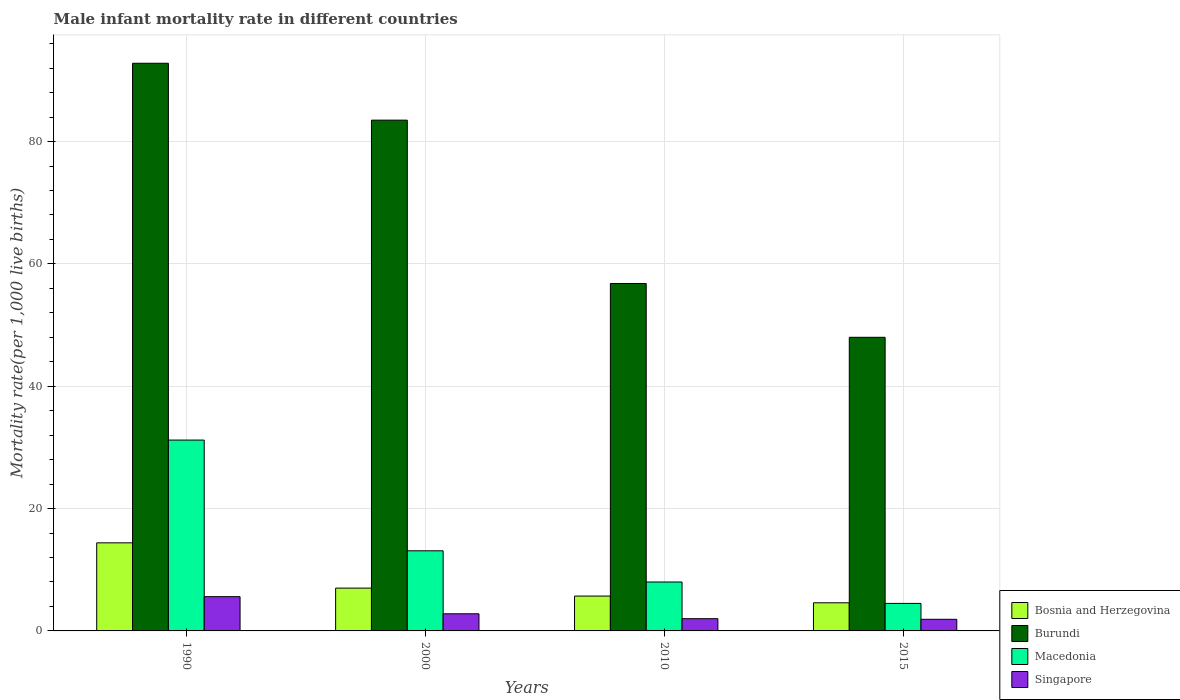How many groups of bars are there?
Keep it short and to the point. 4. Are the number of bars per tick equal to the number of legend labels?
Give a very brief answer. Yes. Are the number of bars on each tick of the X-axis equal?
Your response must be concise. Yes. How many bars are there on the 2nd tick from the left?
Your answer should be compact. 4. How many bars are there on the 3rd tick from the right?
Provide a short and direct response. 4. What is the label of the 2nd group of bars from the left?
Keep it short and to the point. 2000. What is the male infant mortality rate in Burundi in 1990?
Keep it short and to the point. 92.8. Across all years, what is the maximum male infant mortality rate in Bosnia and Herzegovina?
Ensure brevity in your answer.  14.4. Across all years, what is the minimum male infant mortality rate in Singapore?
Give a very brief answer. 1.9. In which year was the male infant mortality rate in Bosnia and Herzegovina minimum?
Provide a succinct answer. 2015. What is the total male infant mortality rate in Macedonia in the graph?
Offer a terse response. 56.8. What is the difference between the male infant mortality rate in Burundi in 2000 and the male infant mortality rate in Bosnia and Herzegovina in 1990?
Your answer should be compact. 69.1. What is the average male infant mortality rate in Bosnia and Herzegovina per year?
Your answer should be very brief. 7.92. In the year 2000, what is the difference between the male infant mortality rate in Singapore and male infant mortality rate in Macedonia?
Offer a terse response. -10.3. What is the ratio of the male infant mortality rate in Singapore in 1990 to that in 2015?
Keep it short and to the point. 2.95. Is the male infant mortality rate in Burundi in 2000 less than that in 2015?
Give a very brief answer. No. In how many years, is the male infant mortality rate in Macedonia greater than the average male infant mortality rate in Macedonia taken over all years?
Your response must be concise. 1. Is the sum of the male infant mortality rate in Macedonia in 1990 and 2010 greater than the maximum male infant mortality rate in Singapore across all years?
Offer a terse response. Yes. What does the 4th bar from the left in 1990 represents?
Your answer should be compact. Singapore. What does the 1st bar from the right in 2010 represents?
Your response must be concise. Singapore. Are all the bars in the graph horizontal?
Provide a short and direct response. No. What is the difference between two consecutive major ticks on the Y-axis?
Make the answer very short. 20. Are the values on the major ticks of Y-axis written in scientific E-notation?
Keep it short and to the point. No. Where does the legend appear in the graph?
Make the answer very short. Bottom right. What is the title of the graph?
Make the answer very short. Male infant mortality rate in different countries. Does "Samoa" appear as one of the legend labels in the graph?
Keep it short and to the point. No. What is the label or title of the Y-axis?
Your answer should be compact. Mortality rate(per 1,0 live births). What is the Mortality rate(per 1,000 live births) in Bosnia and Herzegovina in 1990?
Your response must be concise. 14.4. What is the Mortality rate(per 1,000 live births) in Burundi in 1990?
Provide a succinct answer. 92.8. What is the Mortality rate(per 1,000 live births) of Macedonia in 1990?
Your answer should be compact. 31.2. What is the Mortality rate(per 1,000 live births) of Bosnia and Herzegovina in 2000?
Provide a short and direct response. 7. What is the Mortality rate(per 1,000 live births) in Burundi in 2000?
Your answer should be compact. 83.5. What is the Mortality rate(per 1,000 live births) of Macedonia in 2000?
Give a very brief answer. 13.1. What is the Mortality rate(per 1,000 live births) in Bosnia and Herzegovina in 2010?
Offer a terse response. 5.7. What is the Mortality rate(per 1,000 live births) of Burundi in 2010?
Offer a terse response. 56.8. What is the Mortality rate(per 1,000 live births) of Singapore in 2010?
Your response must be concise. 2. What is the Mortality rate(per 1,000 live births) of Bosnia and Herzegovina in 2015?
Make the answer very short. 4.6. What is the Mortality rate(per 1,000 live births) in Burundi in 2015?
Provide a short and direct response. 48. What is the Mortality rate(per 1,000 live births) in Macedonia in 2015?
Give a very brief answer. 4.5. What is the Mortality rate(per 1,000 live births) in Singapore in 2015?
Provide a succinct answer. 1.9. Across all years, what is the maximum Mortality rate(per 1,000 live births) in Burundi?
Your answer should be compact. 92.8. Across all years, what is the maximum Mortality rate(per 1,000 live births) of Macedonia?
Offer a terse response. 31.2. Across all years, what is the minimum Mortality rate(per 1,000 live births) of Burundi?
Your answer should be compact. 48. Across all years, what is the minimum Mortality rate(per 1,000 live births) in Macedonia?
Provide a succinct answer. 4.5. What is the total Mortality rate(per 1,000 live births) of Bosnia and Herzegovina in the graph?
Your response must be concise. 31.7. What is the total Mortality rate(per 1,000 live births) of Burundi in the graph?
Provide a succinct answer. 281.1. What is the total Mortality rate(per 1,000 live births) of Macedonia in the graph?
Give a very brief answer. 56.8. What is the total Mortality rate(per 1,000 live births) of Singapore in the graph?
Your answer should be very brief. 12.3. What is the difference between the Mortality rate(per 1,000 live births) in Macedonia in 1990 and that in 2000?
Your answer should be very brief. 18.1. What is the difference between the Mortality rate(per 1,000 live births) in Singapore in 1990 and that in 2000?
Ensure brevity in your answer.  2.8. What is the difference between the Mortality rate(per 1,000 live births) in Bosnia and Herzegovina in 1990 and that in 2010?
Offer a terse response. 8.7. What is the difference between the Mortality rate(per 1,000 live births) in Macedonia in 1990 and that in 2010?
Make the answer very short. 23.2. What is the difference between the Mortality rate(per 1,000 live births) in Singapore in 1990 and that in 2010?
Make the answer very short. 3.6. What is the difference between the Mortality rate(per 1,000 live births) in Burundi in 1990 and that in 2015?
Your answer should be very brief. 44.8. What is the difference between the Mortality rate(per 1,000 live births) in Macedonia in 1990 and that in 2015?
Offer a terse response. 26.7. What is the difference between the Mortality rate(per 1,000 live births) of Bosnia and Herzegovina in 2000 and that in 2010?
Ensure brevity in your answer.  1.3. What is the difference between the Mortality rate(per 1,000 live births) in Burundi in 2000 and that in 2010?
Your answer should be very brief. 26.7. What is the difference between the Mortality rate(per 1,000 live births) of Macedonia in 2000 and that in 2010?
Your answer should be very brief. 5.1. What is the difference between the Mortality rate(per 1,000 live births) in Bosnia and Herzegovina in 2000 and that in 2015?
Provide a succinct answer. 2.4. What is the difference between the Mortality rate(per 1,000 live births) of Burundi in 2000 and that in 2015?
Offer a terse response. 35.5. What is the difference between the Mortality rate(per 1,000 live births) of Macedonia in 2000 and that in 2015?
Give a very brief answer. 8.6. What is the difference between the Mortality rate(per 1,000 live births) in Bosnia and Herzegovina in 2010 and that in 2015?
Keep it short and to the point. 1.1. What is the difference between the Mortality rate(per 1,000 live births) of Bosnia and Herzegovina in 1990 and the Mortality rate(per 1,000 live births) of Burundi in 2000?
Your response must be concise. -69.1. What is the difference between the Mortality rate(per 1,000 live births) of Bosnia and Herzegovina in 1990 and the Mortality rate(per 1,000 live births) of Macedonia in 2000?
Make the answer very short. 1.3. What is the difference between the Mortality rate(per 1,000 live births) of Bosnia and Herzegovina in 1990 and the Mortality rate(per 1,000 live births) of Singapore in 2000?
Offer a very short reply. 11.6. What is the difference between the Mortality rate(per 1,000 live births) in Burundi in 1990 and the Mortality rate(per 1,000 live births) in Macedonia in 2000?
Make the answer very short. 79.7. What is the difference between the Mortality rate(per 1,000 live births) of Burundi in 1990 and the Mortality rate(per 1,000 live births) of Singapore in 2000?
Make the answer very short. 90. What is the difference between the Mortality rate(per 1,000 live births) in Macedonia in 1990 and the Mortality rate(per 1,000 live births) in Singapore in 2000?
Offer a terse response. 28.4. What is the difference between the Mortality rate(per 1,000 live births) in Bosnia and Herzegovina in 1990 and the Mortality rate(per 1,000 live births) in Burundi in 2010?
Offer a terse response. -42.4. What is the difference between the Mortality rate(per 1,000 live births) of Burundi in 1990 and the Mortality rate(per 1,000 live births) of Macedonia in 2010?
Make the answer very short. 84.8. What is the difference between the Mortality rate(per 1,000 live births) of Burundi in 1990 and the Mortality rate(per 1,000 live births) of Singapore in 2010?
Provide a succinct answer. 90.8. What is the difference between the Mortality rate(per 1,000 live births) of Macedonia in 1990 and the Mortality rate(per 1,000 live births) of Singapore in 2010?
Give a very brief answer. 29.2. What is the difference between the Mortality rate(per 1,000 live births) in Bosnia and Herzegovina in 1990 and the Mortality rate(per 1,000 live births) in Burundi in 2015?
Make the answer very short. -33.6. What is the difference between the Mortality rate(per 1,000 live births) in Bosnia and Herzegovina in 1990 and the Mortality rate(per 1,000 live births) in Macedonia in 2015?
Your answer should be very brief. 9.9. What is the difference between the Mortality rate(per 1,000 live births) of Burundi in 1990 and the Mortality rate(per 1,000 live births) of Macedonia in 2015?
Give a very brief answer. 88.3. What is the difference between the Mortality rate(per 1,000 live births) of Burundi in 1990 and the Mortality rate(per 1,000 live births) of Singapore in 2015?
Provide a short and direct response. 90.9. What is the difference between the Mortality rate(per 1,000 live births) in Macedonia in 1990 and the Mortality rate(per 1,000 live births) in Singapore in 2015?
Your response must be concise. 29.3. What is the difference between the Mortality rate(per 1,000 live births) of Bosnia and Herzegovina in 2000 and the Mortality rate(per 1,000 live births) of Burundi in 2010?
Offer a terse response. -49.8. What is the difference between the Mortality rate(per 1,000 live births) in Burundi in 2000 and the Mortality rate(per 1,000 live births) in Macedonia in 2010?
Make the answer very short. 75.5. What is the difference between the Mortality rate(per 1,000 live births) of Burundi in 2000 and the Mortality rate(per 1,000 live births) of Singapore in 2010?
Give a very brief answer. 81.5. What is the difference between the Mortality rate(per 1,000 live births) of Macedonia in 2000 and the Mortality rate(per 1,000 live births) of Singapore in 2010?
Give a very brief answer. 11.1. What is the difference between the Mortality rate(per 1,000 live births) in Bosnia and Herzegovina in 2000 and the Mortality rate(per 1,000 live births) in Burundi in 2015?
Make the answer very short. -41. What is the difference between the Mortality rate(per 1,000 live births) of Bosnia and Herzegovina in 2000 and the Mortality rate(per 1,000 live births) of Macedonia in 2015?
Your response must be concise. 2.5. What is the difference between the Mortality rate(per 1,000 live births) in Bosnia and Herzegovina in 2000 and the Mortality rate(per 1,000 live births) in Singapore in 2015?
Your answer should be compact. 5.1. What is the difference between the Mortality rate(per 1,000 live births) in Burundi in 2000 and the Mortality rate(per 1,000 live births) in Macedonia in 2015?
Your answer should be compact. 79. What is the difference between the Mortality rate(per 1,000 live births) in Burundi in 2000 and the Mortality rate(per 1,000 live births) in Singapore in 2015?
Ensure brevity in your answer.  81.6. What is the difference between the Mortality rate(per 1,000 live births) in Macedonia in 2000 and the Mortality rate(per 1,000 live births) in Singapore in 2015?
Your answer should be very brief. 11.2. What is the difference between the Mortality rate(per 1,000 live births) in Bosnia and Herzegovina in 2010 and the Mortality rate(per 1,000 live births) in Burundi in 2015?
Provide a short and direct response. -42.3. What is the difference between the Mortality rate(per 1,000 live births) of Burundi in 2010 and the Mortality rate(per 1,000 live births) of Macedonia in 2015?
Offer a very short reply. 52.3. What is the difference between the Mortality rate(per 1,000 live births) of Burundi in 2010 and the Mortality rate(per 1,000 live births) of Singapore in 2015?
Offer a very short reply. 54.9. What is the average Mortality rate(per 1,000 live births) in Bosnia and Herzegovina per year?
Provide a succinct answer. 7.92. What is the average Mortality rate(per 1,000 live births) of Burundi per year?
Keep it short and to the point. 70.28. What is the average Mortality rate(per 1,000 live births) in Singapore per year?
Make the answer very short. 3.08. In the year 1990, what is the difference between the Mortality rate(per 1,000 live births) in Bosnia and Herzegovina and Mortality rate(per 1,000 live births) in Burundi?
Ensure brevity in your answer.  -78.4. In the year 1990, what is the difference between the Mortality rate(per 1,000 live births) of Bosnia and Herzegovina and Mortality rate(per 1,000 live births) of Macedonia?
Offer a very short reply. -16.8. In the year 1990, what is the difference between the Mortality rate(per 1,000 live births) of Burundi and Mortality rate(per 1,000 live births) of Macedonia?
Your answer should be very brief. 61.6. In the year 1990, what is the difference between the Mortality rate(per 1,000 live births) of Burundi and Mortality rate(per 1,000 live births) of Singapore?
Offer a terse response. 87.2. In the year 1990, what is the difference between the Mortality rate(per 1,000 live births) of Macedonia and Mortality rate(per 1,000 live births) of Singapore?
Your response must be concise. 25.6. In the year 2000, what is the difference between the Mortality rate(per 1,000 live births) in Bosnia and Herzegovina and Mortality rate(per 1,000 live births) in Burundi?
Ensure brevity in your answer.  -76.5. In the year 2000, what is the difference between the Mortality rate(per 1,000 live births) in Burundi and Mortality rate(per 1,000 live births) in Macedonia?
Make the answer very short. 70.4. In the year 2000, what is the difference between the Mortality rate(per 1,000 live births) in Burundi and Mortality rate(per 1,000 live births) in Singapore?
Provide a short and direct response. 80.7. In the year 2000, what is the difference between the Mortality rate(per 1,000 live births) in Macedonia and Mortality rate(per 1,000 live births) in Singapore?
Offer a very short reply. 10.3. In the year 2010, what is the difference between the Mortality rate(per 1,000 live births) of Bosnia and Herzegovina and Mortality rate(per 1,000 live births) of Burundi?
Your answer should be very brief. -51.1. In the year 2010, what is the difference between the Mortality rate(per 1,000 live births) of Bosnia and Herzegovina and Mortality rate(per 1,000 live births) of Macedonia?
Your answer should be very brief. -2.3. In the year 2010, what is the difference between the Mortality rate(per 1,000 live births) in Burundi and Mortality rate(per 1,000 live births) in Macedonia?
Your answer should be very brief. 48.8. In the year 2010, what is the difference between the Mortality rate(per 1,000 live births) in Burundi and Mortality rate(per 1,000 live births) in Singapore?
Make the answer very short. 54.8. In the year 2010, what is the difference between the Mortality rate(per 1,000 live births) of Macedonia and Mortality rate(per 1,000 live births) of Singapore?
Make the answer very short. 6. In the year 2015, what is the difference between the Mortality rate(per 1,000 live births) in Bosnia and Herzegovina and Mortality rate(per 1,000 live births) in Burundi?
Offer a very short reply. -43.4. In the year 2015, what is the difference between the Mortality rate(per 1,000 live births) in Burundi and Mortality rate(per 1,000 live births) in Macedonia?
Make the answer very short. 43.5. In the year 2015, what is the difference between the Mortality rate(per 1,000 live births) in Burundi and Mortality rate(per 1,000 live births) in Singapore?
Provide a succinct answer. 46.1. What is the ratio of the Mortality rate(per 1,000 live births) in Bosnia and Herzegovina in 1990 to that in 2000?
Your answer should be compact. 2.06. What is the ratio of the Mortality rate(per 1,000 live births) of Burundi in 1990 to that in 2000?
Provide a succinct answer. 1.11. What is the ratio of the Mortality rate(per 1,000 live births) in Macedonia in 1990 to that in 2000?
Your answer should be compact. 2.38. What is the ratio of the Mortality rate(per 1,000 live births) in Bosnia and Herzegovina in 1990 to that in 2010?
Provide a short and direct response. 2.53. What is the ratio of the Mortality rate(per 1,000 live births) of Burundi in 1990 to that in 2010?
Make the answer very short. 1.63. What is the ratio of the Mortality rate(per 1,000 live births) in Macedonia in 1990 to that in 2010?
Ensure brevity in your answer.  3.9. What is the ratio of the Mortality rate(per 1,000 live births) of Bosnia and Herzegovina in 1990 to that in 2015?
Offer a very short reply. 3.13. What is the ratio of the Mortality rate(per 1,000 live births) of Burundi in 1990 to that in 2015?
Ensure brevity in your answer.  1.93. What is the ratio of the Mortality rate(per 1,000 live births) of Macedonia in 1990 to that in 2015?
Provide a succinct answer. 6.93. What is the ratio of the Mortality rate(per 1,000 live births) in Singapore in 1990 to that in 2015?
Provide a succinct answer. 2.95. What is the ratio of the Mortality rate(per 1,000 live births) in Bosnia and Herzegovina in 2000 to that in 2010?
Ensure brevity in your answer.  1.23. What is the ratio of the Mortality rate(per 1,000 live births) in Burundi in 2000 to that in 2010?
Offer a very short reply. 1.47. What is the ratio of the Mortality rate(per 1,000 live births) of Macedonia in 2000 to that in 2010?
Ensure brevity in your answer.  1.64. What is the ratio of the Mortality rate(per 1,000 live births) in Singapore in 2000 to that in 2010?
Your response must be concise. 1.4. What is the ratio of the Mortality rate(per 1,000 live births) in Bosnia and Herzegovina in 2000 to that in 2015?
Provide a short and direct response. 1.52. What is the ratio of the Mortality rate(per 1,000 live births) of Burundi in 2000 to that in 2015?
Ensure brevity in your answer.  1.74. What is the ratio of the Mortality rate(per 1,000 live births) in Macedonia in 2000 to that in 2015?
Provide a succinct answer. 2.91. What is the ratio of the Mortality rate(per 1,000 live births) in Singapore in 2000 to that in 2015?
Provide a short and direct response. 1.47. What is the ratio of the Mortality rate(per 1,000 live births) in Bosnia and Herzegovina in 2010 to that in 2015?
Keep it short and to the point. 1.24. What is the ratio of the Mortality rate(per 1,000 live births) of Burundi in 2010 to that in 2015?
Provide a short and direct response. 1.18. What is the ratio of the Mortality rate(per 1,000 live births) of Macedonia in 2010 to that in 2015?
Ensure brevity in your answer.  1.78. What is the ratio of the Mortality rate(per 1,000 live births) of Singapore in 2010 to that in 2015?
Your answer should be very brief. 1.05. What is the difference between the highest and the second highest Mortality rate(per 1,000 live births) in Bosnia and Herzegovina?
Provide a succinct answer. 7.4. What is the difference between the highest and the lowest Mortality rate(per 1,000 live births) in Burundi?
Offer a very short reply. 44.8. What is the difference between the highest and the lowest Mortality rate(per 1,000 live births) of Macedonia?
Give a very brief answer. 26.7. What is the difference between the highest and the lowest Mortality rate(per 1,000 live births) of Singapore?
Offer a terse response. 3.7. 